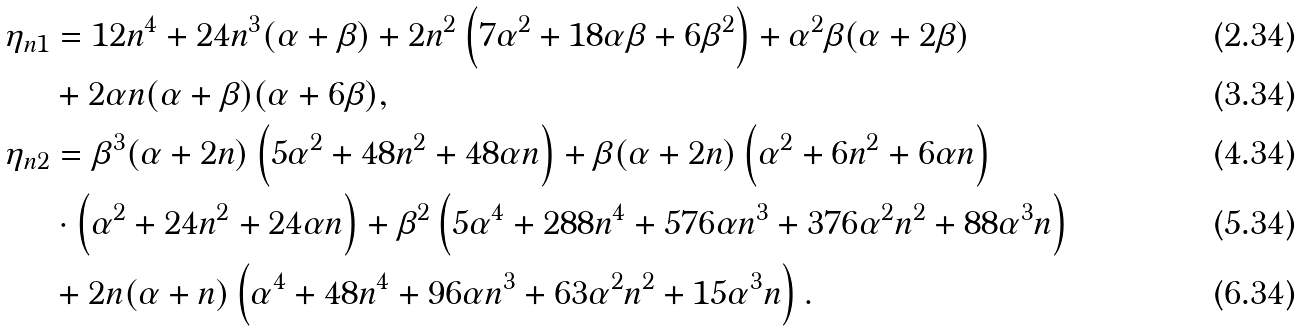Convert formula to latex. <formula><loc_0><loc_0><loc_500><loc_500>\eta _ { n 1 } & = 1 2 n ^ { 4 } + 2 4 n ^ { 3 } ( \alpha + \beta ) + 2 n ^ { 2 } \left ( 7 \alpha ^ { 2 } + 1 8 \alpha \beta + 6 \beta ^ { 2 } \right ) + \alpha ^ { 2 } \beta ( \alpha + 2 \beta ) \\ & + 2 \alpha n ( \alpha + \beta ) ( \alpha + 6 \beta ) , \\ \eta _ { n 2 } & = \beta ^ { 3 } ( \alpha + 2 n ) \left ( 5 \alpha ^ { 2 } + 4 8 n ^ { 2 } + 4 8 \alpha n \right ) + \beta ( \alpha + 2 n ) \left ( \alpha ^ { 2 } + 6 n ^ { 2 } + 6 \alpha n \right ) \\ & \cdot \left ( \alpha ^ { 2 } + 2 4 n ^ { 2 } + 2 4 \alpha n \right ) + \beta ^ { 2 } \left ( 5 \alpha ^ { 4 } + 2 8 8 n ^ { 4 } + 5 7 6 \alpha n ^ { 3 } + 3 7 6 \alpha ^ { 2 } n ^ { 2 } + 8 8 \alpha ^ { 3 } n \right ) \\ & + 2 n ( \alpha + n ) \left ( \alpha ^ { 4 } + 4 8 n ^ { 4 } + 9 6 \alpha n ^ { 3 } + 6 3 \alpha ^ { 2 } n ^ { 2 } + 1 5 \alpha ^ { 3 } n \right ) .</formula> 